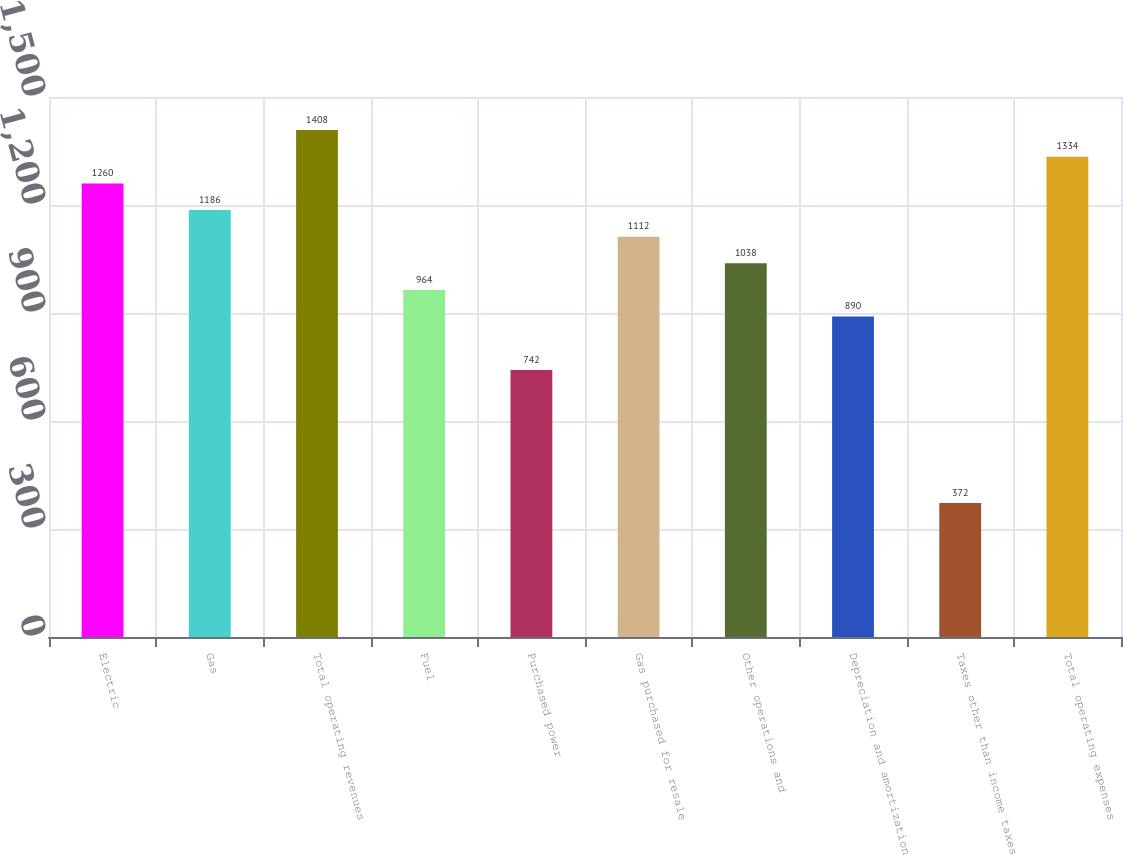<chart> <loc_0><loc_0><loc_500><loc_500><bar_chart><fcel>Electric<fcel>Gas<fcel>Total operating revenues<fcel>Fuel<fcel>Purchased power<fcel>Gas purchased for resale<fcel>Other operations and<fcel>Depreciation and amortization<fcel>Taxes other than income taxes<fcel>Total operating expenses<nl><fcel>1260<fcel>1186<fcel>1408<fcel>964<fcel>742<fcel>1112<fcel>1038<fcel>890<fcel>372<fcel>1334<nl></chart> 